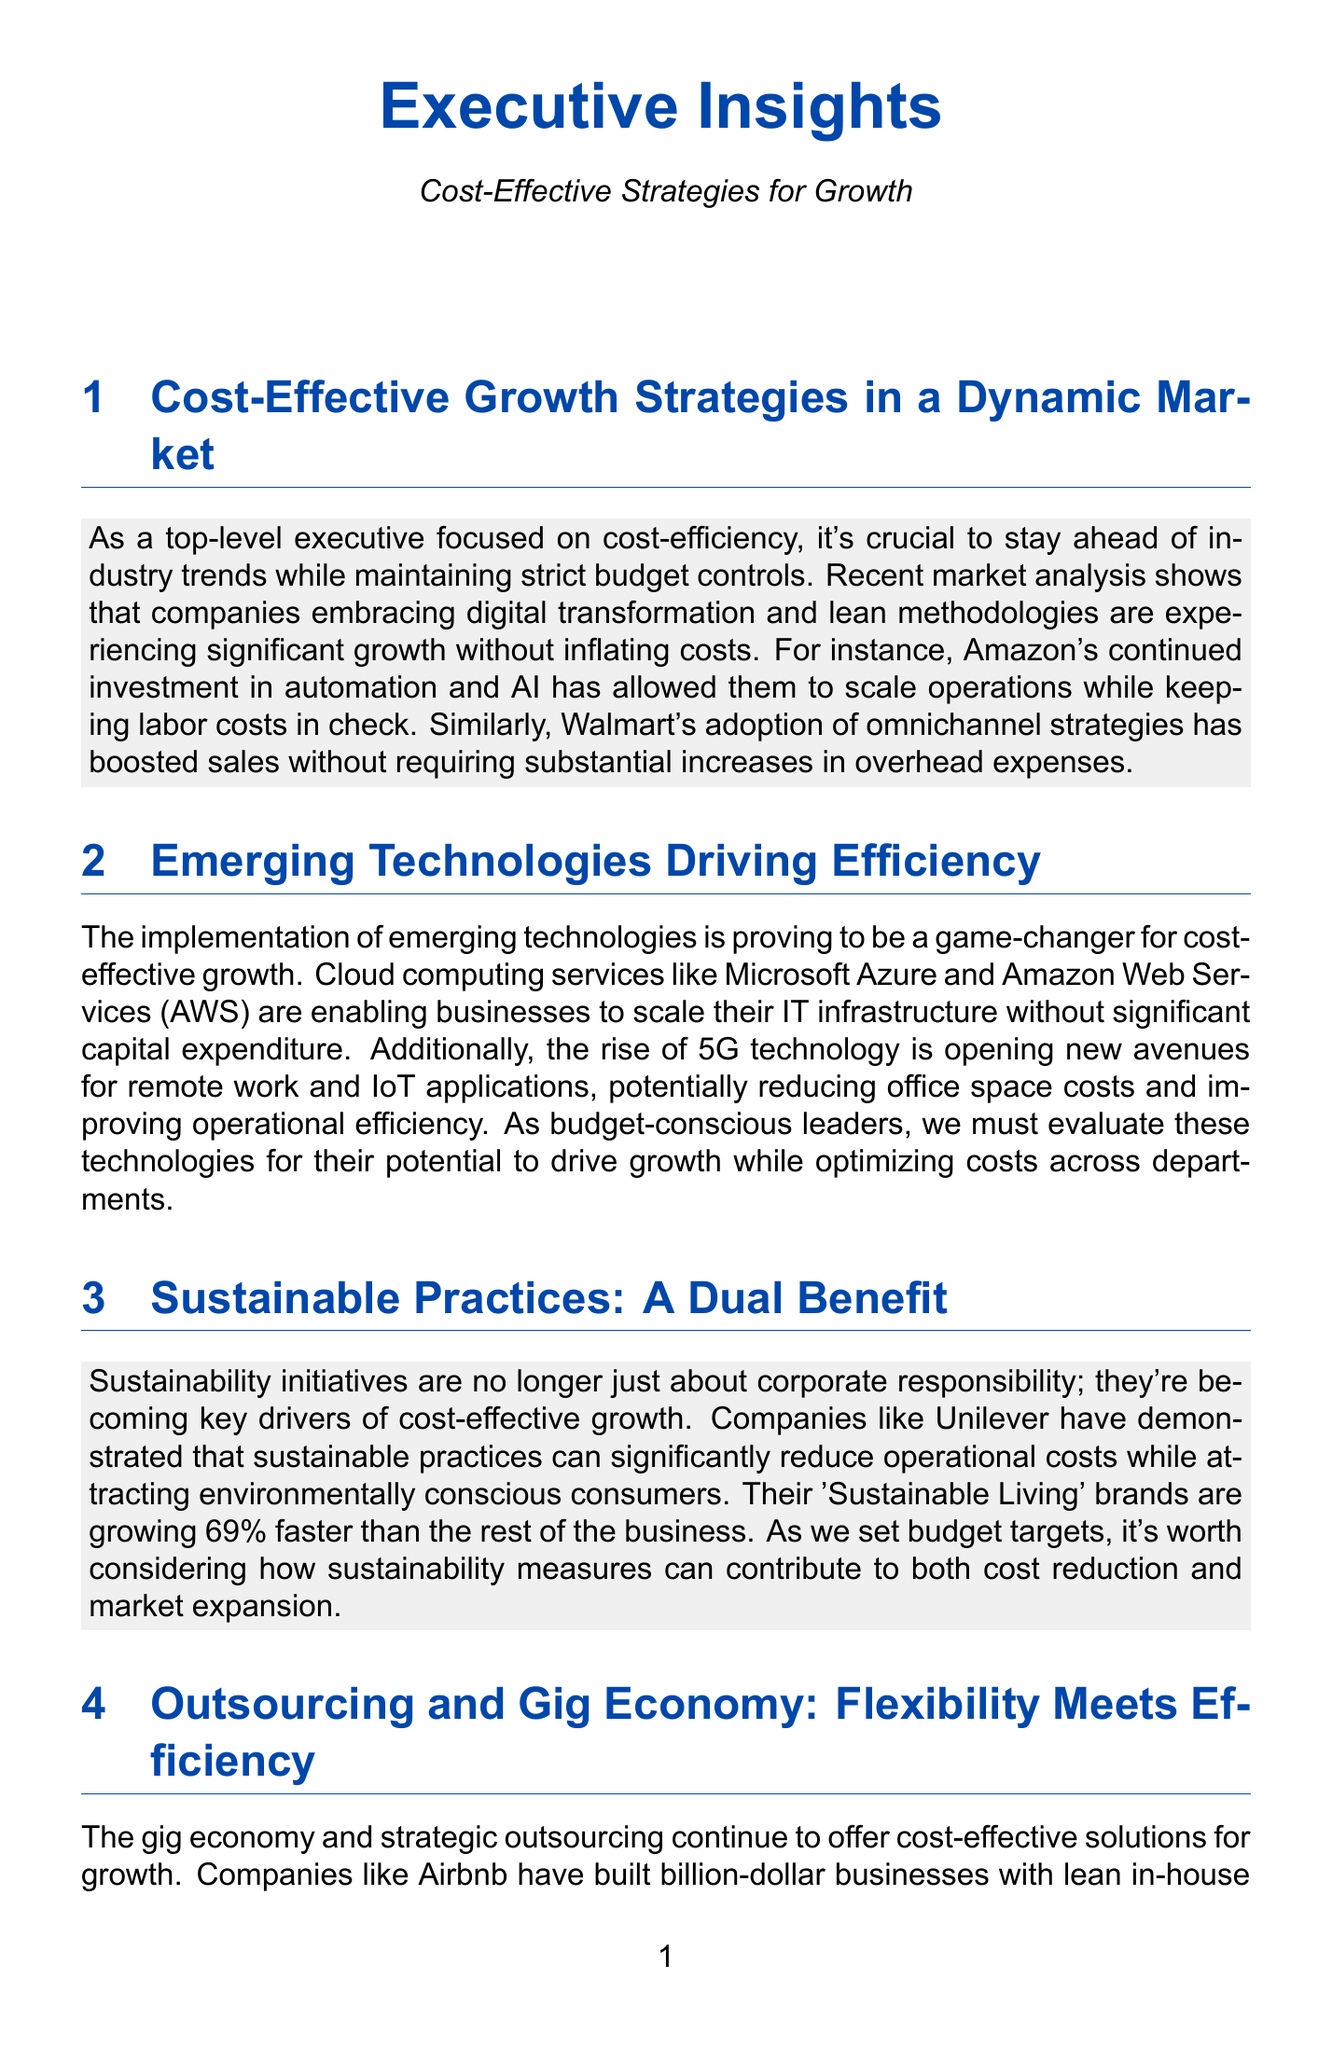What is the main focus of the newsletter? The newsletter emphasizes the importance of cost-effective strategies for growth while navigating industry trends.
Answer: Cost-effective strategies for growth Which two companies are mentioned for their digital transformation strategies? Amazon and Walmart are highlighted in the newsletter for their effective strategies in maintaining costs.
Answer: Amazon, Walmart What percentage faster are Unilever's 'Sustainable Living' brands growing compared to the rest of the business? The text states that these brands are growing 69% faster than the rest of the business.
Answer: 69% What emerging technology is mentioned for reducing office space costs? The rise of 5G technology is indicated as a means to potentially reduce office space costs.
Answer: 5G technology What method is suggested to foster innovation without excessive spending? The newsletter suggests adopting lean startup methodologies to promote innovation cost-effectively.
Answer: Lean startup methodologies Which technology services are noted for enabling businesses to scale their IT infrastructure? The newsletter refers to Microsoft Azure and Amazon Web Services as key technology services.
Answer: Microsoft Azure, Amazon Web Services What approach is recommended for utilizing external resources? The newsletter recommends using gig economy strategies and outsourcing for flexibility and efficiency.
Answer: Gig economy, outsourcing Which company is used as an example for adopting a lean startup principle? General Electric is cited as an example of a company implementing lean startup methodologies.
Answer: General Electric 